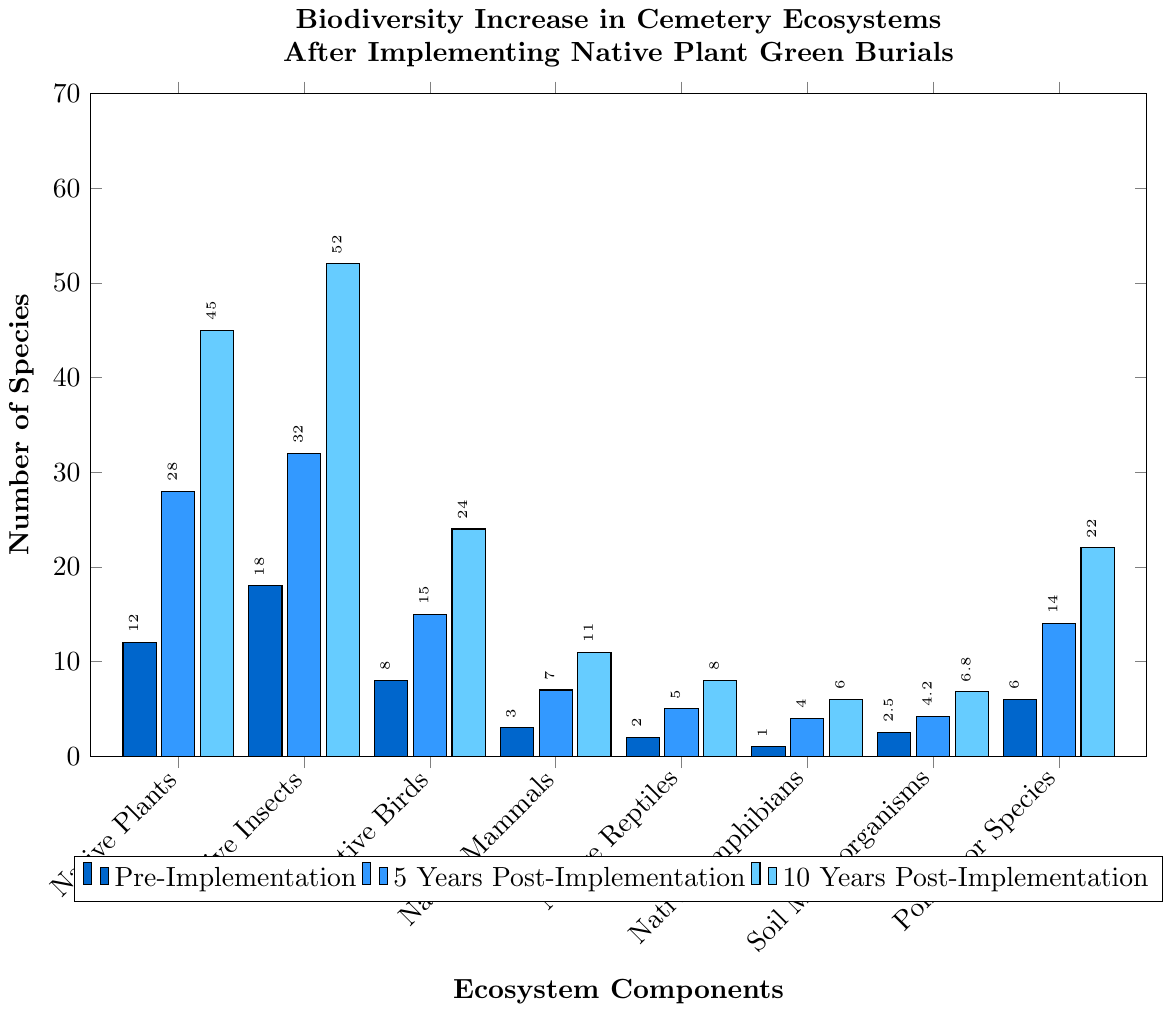Comparing the number of native insect species, which time point shows the greatest increase? By observing the bars for native insects, the pre-implementation count is 18, 5 years post-implementation is 32, and 10 years post-implementation is 52. The greatest increase happens from pre-implementation to 10 years post-implementation.
Answer: 10 years post-implementation What is the total number of native bird species at all three time points combined? Adding the number of native bird species across all three time points: 8 (pre-implementation) + 15 (5 years post-implementation) + 24 (10 years post-implementation) = 47.
Answer: 47 Which ecosystem component had the smallest number of species pre-implementation? Examining the shortest bars for pre-implementation, native amphibians had the smallest number at 1 species.
Answer: Native amphibians How much did the number of pollinator species increase from pre-implementation to 5 years post-implementation? The number of pollinator species increased from 6 (pre-implementation) to 14 (5 years post-implementation). Subtracting these values gives 14 - 6 = 8.
Answer: 8 Which category shows the largest increase in species count from 5 years post-implementation to 10 years post-implementation? Comparing the increase across all categories, native insects went from 32 (5 years post-implementation) to 52 (10 years post-implementation), which is an increase of 20 species. This is the largest increase.
Answer: Native insects What is the average number of soil microorganisms in billions/m³ across all time points? Adding the number of soil microorganisms values: 2.5 (pre-implementation) + 4.2 (5 years post-implementation) + 6.8 (10 years post-implementation) = 13.5. Dividing this by the 3 time points: 13.5 / 3 = 4.5.
Answer: 4.5 